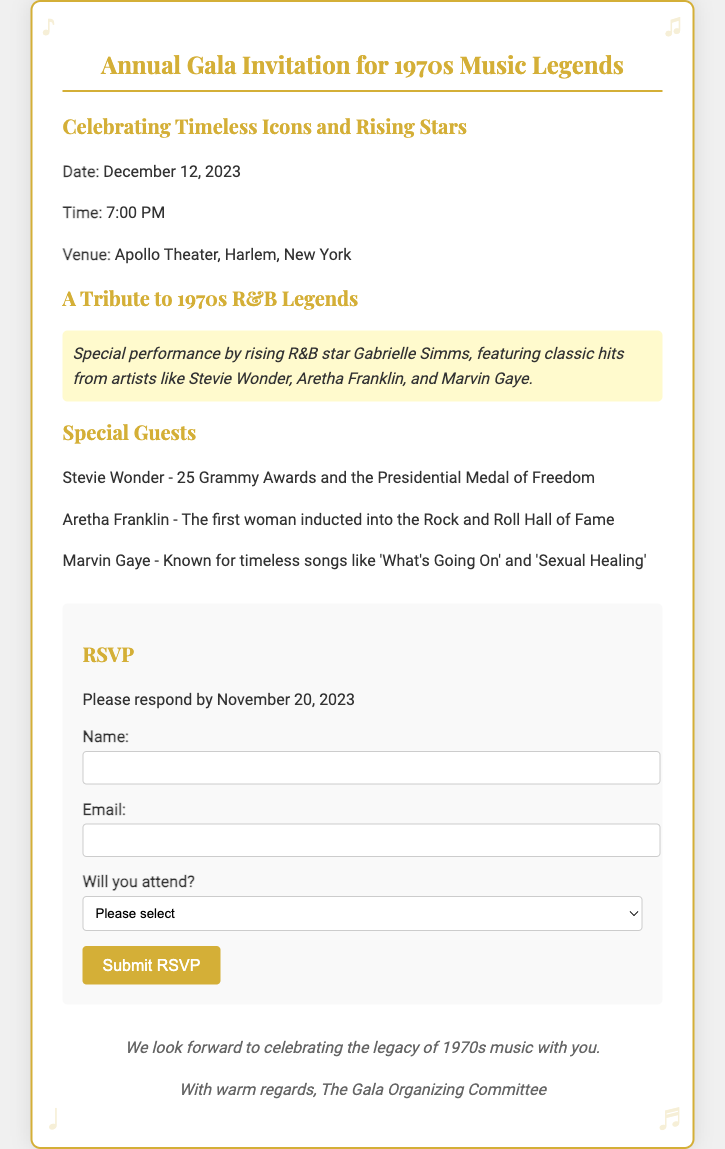What is the date of the gala? The date of the gala is explicitly mentioned in the document as December 12, 2023.
Answer: December 12, 2023 What is the venue for the event? The document states that the venue for the event is the Apollo Theater, Harlem, New York.
Answer: Apollo Theater, Harlem, New York Who is the special performer? The document highlights that Gabrielle Simms is the special performer for the gala.
Answer: Gabrielle Simms What is the RSVP deadline? The RSVP deadline is provided in the document as November 20, 2023.
Answer: November 20, 2023 How many Grammy Awards does Stevie Wonder have? The document mentions that Stevie Wonder has 25 Grammy Awards.
Answer: 25 Grammy Awards What genre of music is being celebrated? The document indicates that the gala celebrates R&B music.
Answer: R&B What is the time for the gala? The time for the gala is specified in the document as 7:00 PM.
Answer: 7:00 PM What type of document is this? The document is an RSVP card for an annual gala invitation.
Answer: RSVP card Will there be a tribute performance? The document states there will be a tribute performance by rising R&B stars.
Answer: Yes, a tribute performance 